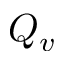<formula> <loc_0><loc_0><loc_500><loc_500>Q _ { v }</formula> 